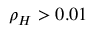<formula> <loc_0><loc_0><loc_500><loc_500>\rho _ { H } > 0 . 0 1</formula> 